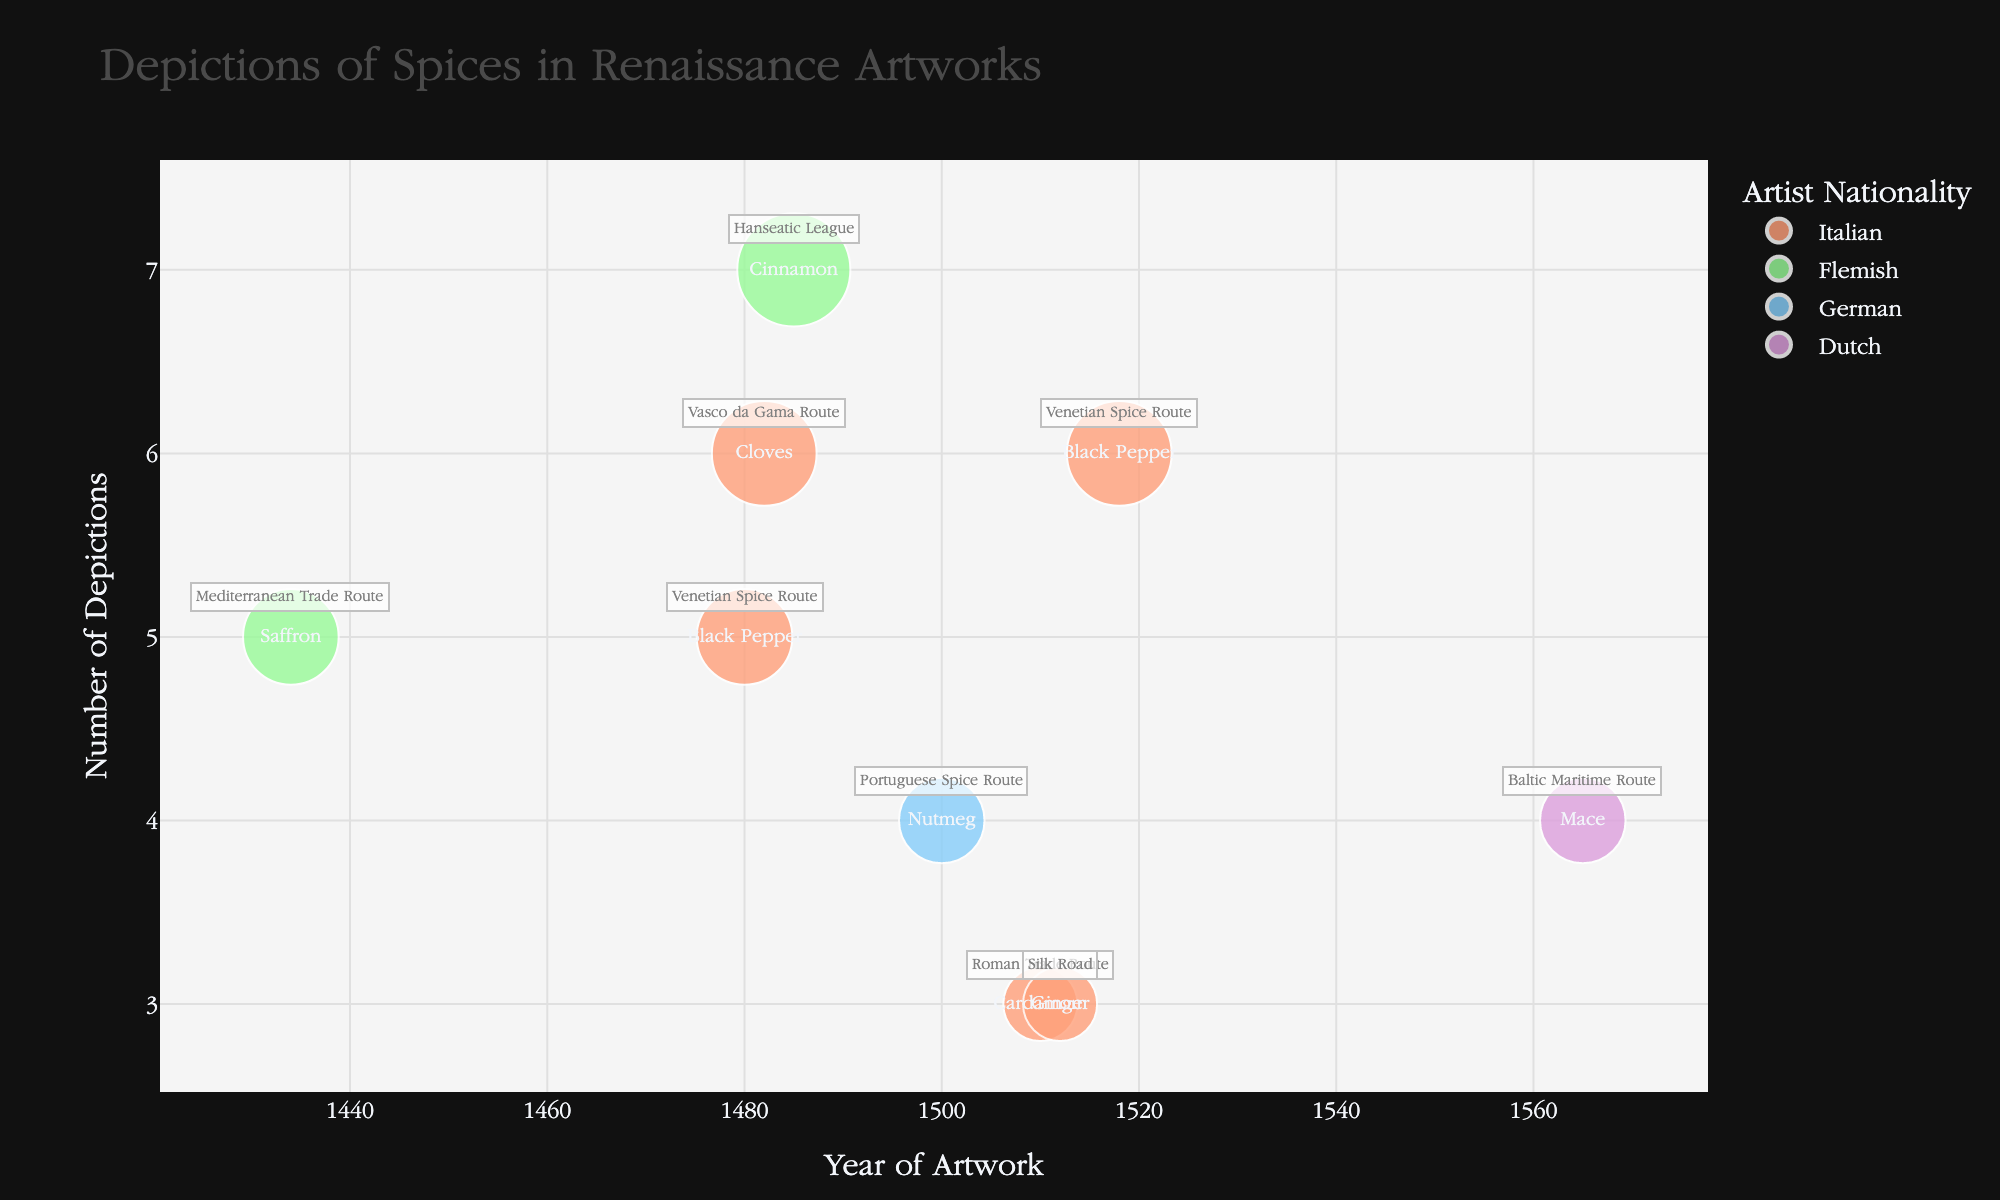How many artworks depicting spices were created by Italian artists? Count the bubbles in the color representing Italian artists. 5 bubbles appear for Italian artists.
Answer: 5 Which artist depicted Nutmeg and on which trade route was it related? Locate the bubble with the text "Nutmeg" and check the hover or annotation for the trade route. The text shows "Albrecht Dürer" and "Portuguese Spice Route".
Answer: Albrecht Dürer, Portuguese Spice Route Which spice has the highest depiction count, and who is the artist? Look for the largest bubble and note its spice and the artist's name in the hover text. The largest bubble is "Cinnamon" by "Hans Memling".
Answer: Cinnamon, Hans Memling Between the years 1510 and 1518, which spice was depicted by more than one artist? Check the bubbles in the specified year range and count the spices. "Black Pepper" appears twice within this range.
Answer: Black Pepper How does the depiction count of "Black Pepper" by Giovanni Bellini compare to that by Raphael Sanzio? Locate and compare the "Black Pepper" bubbles for both artists. Giovanni Bellini has 5 depictions, while Raphael Sanzio has 6.
Answer: Raphael Sanzio has one more depiction than Giovanni Bellini Which nationality represented the most diverse range of spices in artworks? Examine the text labels for different spices within each nationality color. Italians depicted 5 spices (Black Pepper, Cloves, Cardamom, Ginger).
Answer: Italian In what year did Jan van Eyck depict Saffron and which trade route was it associated with? Find the bubble with the spice "Saffron" and check the year and trade route in the hover text. The year is 1434, and the trade route is Mediterranean Trade Route.
Answer: 1434, Mediterranean Trade Route What is the difference in depiction counts between the highest and lowest depicted spices? Identify the largest and smallest bubbles and subtract their counts. The highest count is 7 (Cinnamon) and the lowest is 3 (Cardamom, Ginger), 7-3 = 4.
Answer: 4 Which spice is depicted along the Vasco da Gama Route and by which artist? Locate the annotation "Vasco da Gama Route", check the text, and hover to find the spice and artist. Cloves depicted by Sandro Botticelli.
Answer: Cloves, Sandro Botticelli 